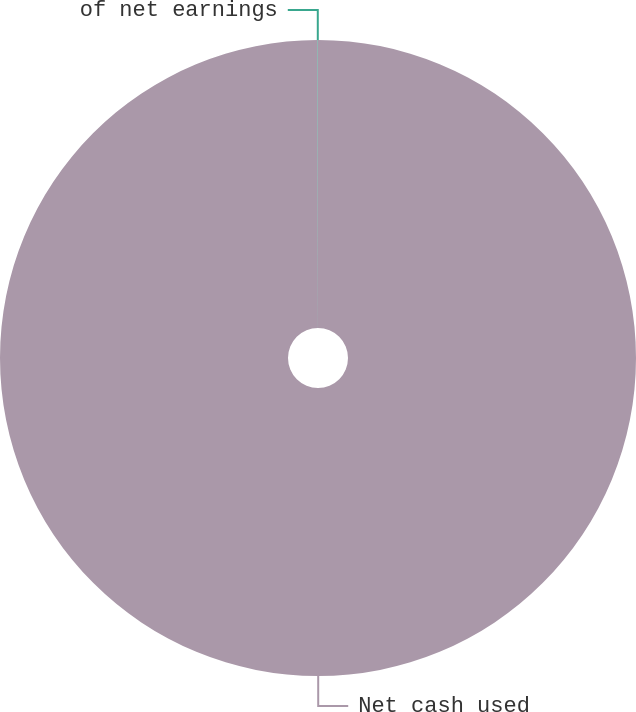Convert chart to OTSL. <chart><loc_0><loc_0><loc_500><loc_500><pie_chart><fcel>Net cash used<fcel>of net earnings<nl><fcel>99.98%<fcel>0.02%<nl></chart> 